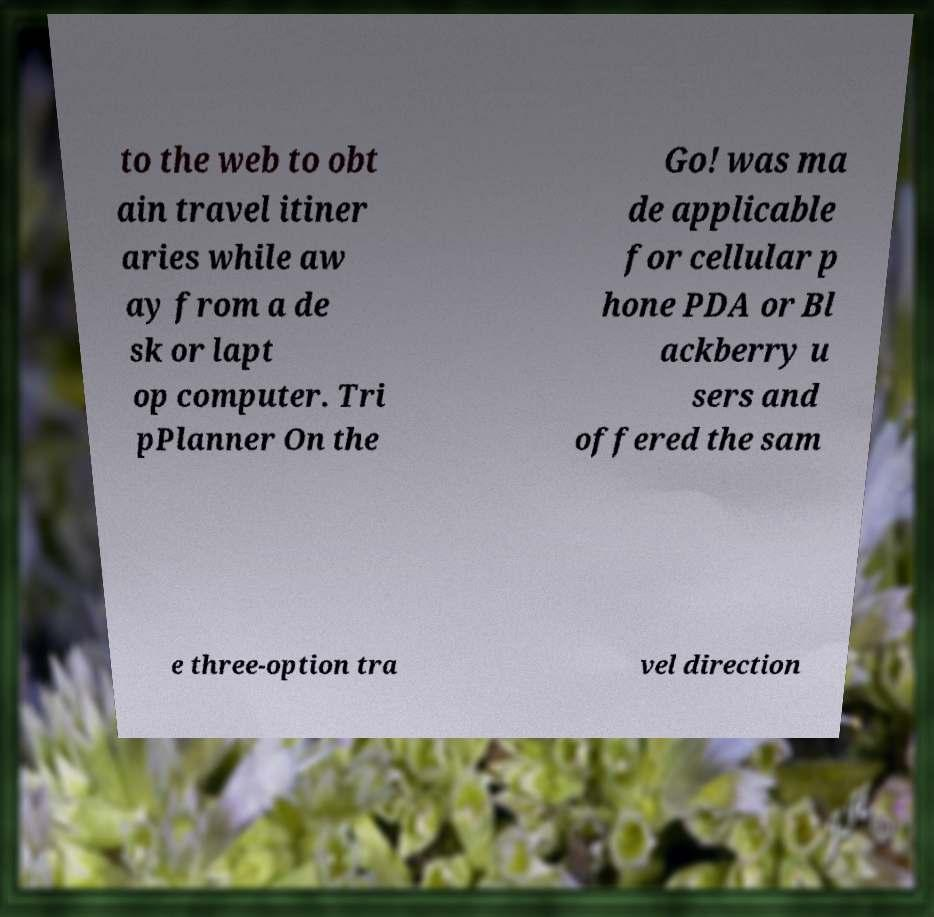Could you assist in decoding the text presented in this image and type it out clearly? to the web to obt ain travel itiner aries while aw ay from a de sk or lapt op computer. Tri pPlanner On the Go! was ma de applicable for cellular p hone PDA or Bl ackberry u sers and offered the sam e three-option tra vel direction 